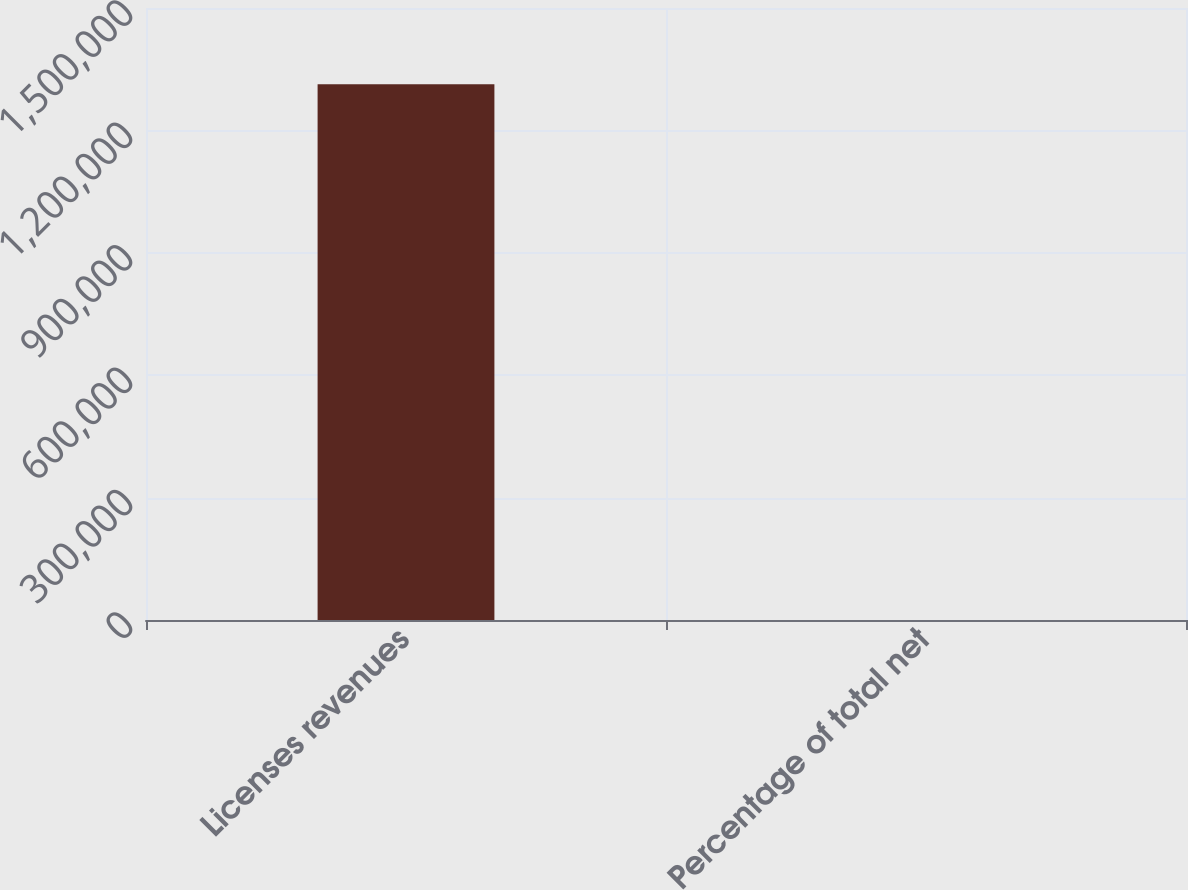Convert chart to OTSL. <chart><loc_0><loc_0><loc_500><loc_500><bar_chart><fcel>Licenses revenues<fcel>Percentage of total net<nl><fcel>1.31285e+06<fcel>22<nl></chart> 